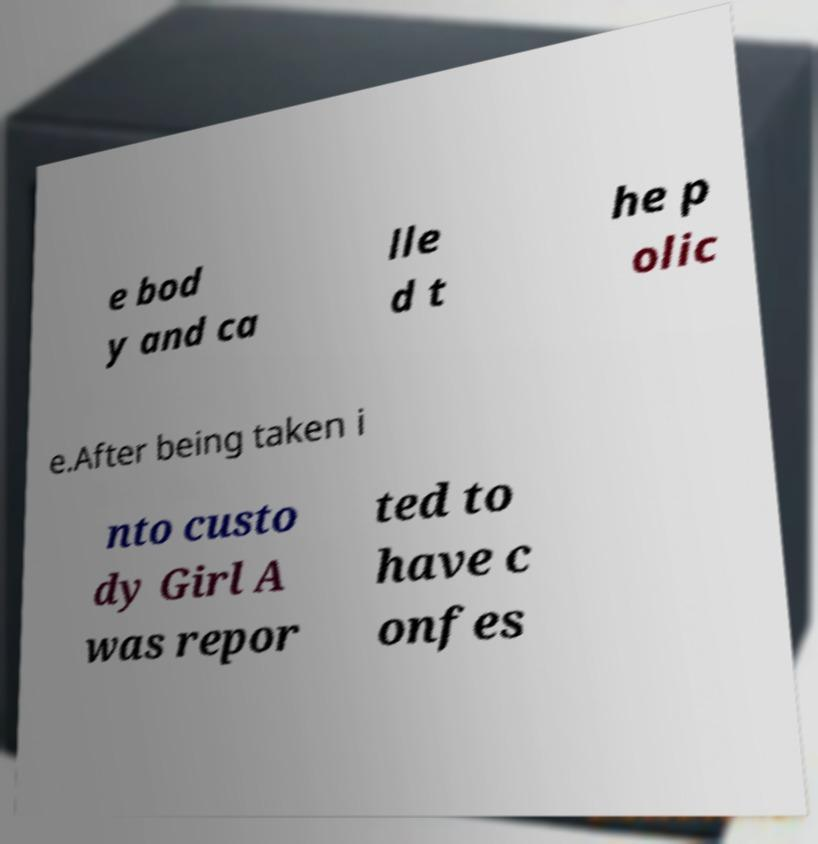What messages or text are displayed in this image? I need them in a readable, typed format. e bod y and ca lle d t he p olic e.After being taken i nto custo dy Girl A was repor ted to have c onfes 